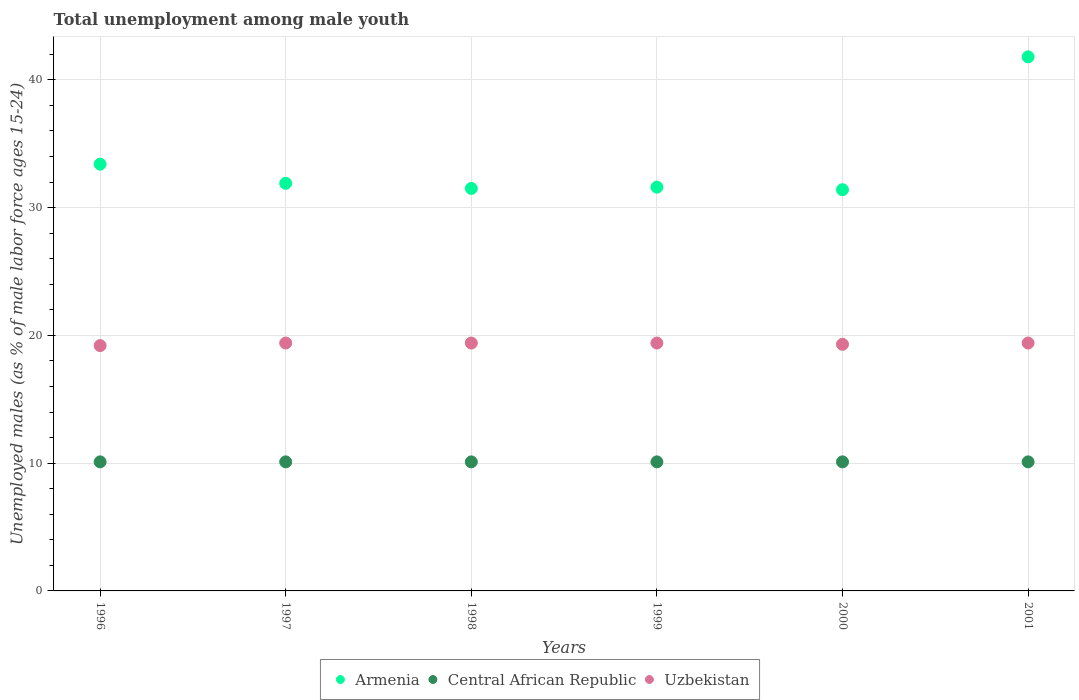How many different coloured dotlines are there?
Ensure brevity in your answer.  3. Is the number of dotlines equal to the number of legend labels?
Your answer should be compact. Yes. What is the percentage of unemployed males in in Central African Republic in 1996?
Offer a very short reply. 10.1. Across all years, what is the maximum percentage of unemployed males in in Armenia?
Offer a very short reply. 41.8. Across all years, what is the minimum percentage of unemployed males in in Central African Republic?
Your answer should be compact. 10.1. What is the total percentage of unemployed males in in Armenia in the graph?
Your answer should be very brief. 201.6. What is the difference between the percentage of unemployed males in in Central African Republic in 1998 and that in 1999?
Provide a succinct answer. 0. What is the difference between the percentage of unemployed males in in Uzbekistan in 1997 and the percentage of unemployed males in in Central African Republic in 1996?
Your answer should be compact. 9.3. What is the average percentage of unemployed males in in Uzbekistan per year?
Provide a succinct answer. 19.35. In the year 1998, what is the difference between the percentage of unemployed males in in Armenia and percentage of unemployed males in in Central African Republic?
Your response must be concise. 21.4. In how many years, is the percentage of unemployed males in in Armenia greater than 2 %?
Offer a terse response. 6. What is the ratio of the percentage of unemployed males in in Armenia in 1997 to that in 1998?
Provide a succinct answer. 1.01. Is the difference between the percentage of unemployed males in in Armenia in 1998 and 2001 greater than the difference between the percentage of unemployed males in in Central African Republic in 1998 and 2001?
Make the answer very short. No. What is the difference between the highest and the lowest percentage of unemployed males in in Armenia?
Provide a short and direct response. 10.4. Is it the case that in every year, the sum of the percentage of unemployed males in in Uzbekistan and percentage of unemployed males in in Armenia  is greater than the percentage of unemployed males in in Central African Republic?
Provide a succinct answer. Yes. Is the percentage of unemployed males in in Armenia strictly greater than the percentage of unemployed males in in Central African Republic over the years?
Offer a terse response. Yes. How many dotlines are there?
Ensure brevity in your answer.  3. How many years are there in the graph?
Keep it short and to the point. 6. Does the graph contain any zero values?
Keep it short and to the point. No. Does the graph contain grids?
Your answer should be compact. Yes. Where does the legend appear in the graph?
Make the answer very short. Bottom center. How many legend labels are there?
Offer a terse response. 3. How are the legend labels stacked?
Offer a terse response. Horizontal. What is the title of the graph?
Offer a very short reply. Total unemployment among male youth. What is the label or title of the Y-axis?
Offer a very short reply. Unemployed males (as % of male labor force ages 15-24). What is the Unemployed males (as % of male labor force ages 15-24) in Armenia in 1996?
Ensure brevity in your answer.  33.4. What is the Unemployed males (as % of male labor force ages 15-24) of Central African Republic in 1996?
Offer a very short reply. 10.1. What is the Unemployed males (as % of male labor force ages 15-24) of Uzbekistan in 1996?
Your answer should be very brief. 19.2. What is the Unemployed males (as % of male labor force ages 15-24) in Armenia in 1997?
Your answer should be compact. 31.9. What is the Unemployed males (as % of male labor force ages 15-24) in Central African Republic in 1997?
Make the answer very short. 10.1. What is the Unemployed males (as % of male labor force ages 15-24) of Uzbekistan in 1997?
Ensure brevity in your answer.  19.4. What is the Unemployed males (as % of male labor force ages 15-24) in Armenia in 1998?
Give a very brief answer. 31.5. What is the Unemployed males (as % of male labor force ages 15-24) of Central African Republic in 1998?
Your answer should be very brief. 10.1. What is the Unemployed males (as % of male labor force ages 15-24) of Uzbekistan in 1998?
Provide a succinct answer. 19.4. What is the Unemployed males (as % of male labor force ages 15-24) in Armenia in 1999?
Provide a short and direct response. 31.6. What is the Unemployed males (as % of male labor force ages 15-24) in Central African Republic in 1999?
Provide a succinct answer. 10.1. What is the Unemployed males (as % of male labor force ages 15-24) of Uzbekistan in 1999?
Give a very brief answer. 19.4. What is the Unemployed males (as % of male labor force ages 15-24) of Armenia in 2000?
Keep it short and to the point. 31.4. What is the Unemployed males (as % of male labor force ages 15-24) of Central African Republic in 2000?
Your answer should be compact. 10.1. What is the Unemployed males (as % of male labor force ages 15-24) of Uzbekistan in 2000?
Make the answer very short. 19.3. What is the Unemployed males (as % of male labor force ages 15-24) in Armenia in 2001?
Make the answer very short. 41.8. What is the Unemployed males (as % of male labor force ages 15-24) of Central African Republic in 2001?
Offer a terse response. 10.1. What is the Unemployed males (as % of male labor force ages 15-24) of Uzbekistan in 2001?
Give a very brief answer. 19.4. Across all years, what is the maximum Unemployed males (as % of male labor force ages 15-24) of Armenia?
Offer a terse response. 41.8. Across all years, what is the maximum Unemployed males (as % of male labor force ages 15-24) in Central African Republic?
Provide a short and direct response. 10.1. Across all years, what is the maximum Unemployed males (as % of male labor force ages 15-24) of Uzbekistan?
Keep it short and to the point. 19.4. Across all years, what is the minimum Unemployed males (as % of male labor force ages 15-24) of Armenia?
Keep it short and to the point. 31.4. Across all years, what is the minimum Unemployed males (as % of male labor force ages 15-24) in Central African Republic?
Ensure brevity in your answer.  10.1. Across all years, what is the minimum Unemployed males (as % of male labor force ages 15-24) of Uzbekistan?
Provide a short and direct response. 19.2. What is the total Unemployed males (as % of male labor force ages 15-24) in Armenia in the graph?
Provide a succinct answer. 201.6. What is the total Unemployed males (as % of male labor force ages 15-24) in Central African Republic in the graph?
Provide a short and direct response. 60.6. What is the total Unemployed males (as % of male labor force ages 15-24) in Uzbekistan in the graph?
Give a very brief answer. 116.1. What is the difference between the Unemployed males (as % of male labor force ages 15-24) in Armenia in 1996 and that in 1997?
Your response must be concise. 1.5. What is the difference between the Unemployed males (as % of male labor force ages 15-24) in Uzbekistan in 1996 and that in 1997?
Ensure brevity in your answer.  -0.2. What is the difference between the Unemployed males (as % of male labor force ages 15-24) of Armenia in 1996 and that in 1999?
Keep it short and to the point. 1.8. What is the difference between the Unemployed males (as % of male labor force ages 15-24) in Central African Republic in 1996 and that in 1999?
Offer a very short reply. 0. What is the difference between the Unemployed males (as % of male labor force ages 15-24) in Armenia in 1996 and that in 2000?
Provide a short and direct response. 2. What is the difference between the Unemployed males (as % of male labor force ages 15-24) in Central African Republic in 1996 and that in 2000?
Your answer should be very brief. 0. What is the difference between the Unemployed males (as % of male labor force ages 15-24) of Armenia in 1996 and that in 2001?
Your answer should be very brief. -8.4. What is the difference between the Unemployed males (as % of male labor force ages 15-24) in Uzbekistan in 1996 and that in 2001?
Your answer should be compact. -0.2. What is the difference between the Unemployed males (as % of male labor force ages 15-24) of Uzbekistan in 1997 and that in 1998?
Offer a terse response. 0. What is the difference between the Unemployed males (as % of male labor force ages 15-24) of Central African Republic in 1997 and that in 1999?
Ensure brevity in your answer.  0. What is the difference between the Unemployed males (as % of male labor force ages 15-24) in Armenia in 1997 and that in 2000?
Provide a short and direct response. 0.5. What is the difference between the Unemployed males (as % of male labor force ages 15-24) in Central African Republic in 1997 and that in 2000?
Offer a very short reply. 0. What is the difference between the Unemployed males (as % of male labor force ages 15-24) in Armenia in 1997 and that in 2001?
Keep it short and to the point. -9.9. What is the difference between the Unemployed males (as % of male labor force ages 15-24) in Uzbekistan in 1997 and that in 2001?
Give a very brief answer. 0. What is the difference between the Unemployed males (as % of male labor force ages 15-24) in Central African Republic in 1998 and that in 1999?
Offer a terse response. 0. What is the difference between the Unemployed males (as % of male labor force ages 15-24) in Uzbekistan in 1998 and that in 1999?
Provide a succinct answer. 0. What is the difference between the Unemployed males (as % of male labor force ages 15-24) in Central African Republic in 1998 and that in 2000?
Provide a short and direct response. 0. What is the difference between the Unemployed males (as % of male labor force ages 15-24) of Central African Republic in 1999 and that in 2000?
Give a very brief answer. 0. What is the difference between the Unemployed males (as % of male labor force ages 15-24) of Uzbekistan in 1999 and that in 2001?
Provide a succinct answer. 0. What is the difference between the Unemployed males (as % of male labor force ages 15-24) of Armenia in 2000 and that in 2001?
Offer a terse response. -10.4. What is the difference between the Unemployed males (as % of male labor force ages 15-24) in Central African Republic in 2000 and that in 2001?
Your answer should be compact. 0. What is the difference between the Unemployed males (as % of male labor force ages 15-24) in Armenia in 1996 and the Unemployed males (as % of male labor force ages 15-24) in Central African Republic in 1997?
Ensure brevity in your answer.  23.3. What is the difference between the Unemployed males (as % of male labor force ages 15-24) of Armenia in 1996 and the Unemployed males (as % of male labor force ages 15-24) of Uzbekistan in 1997?
Ensure brevity in your answer.  14. What is the difference between the Unemployed males (as % of male labor force ages 15-24) of Armenia in 1996 and the Unemployed males (as % of male labor force ages 15-24) of Central African Republic in 1998?
Give a very brief answer. 23.3. What is the difference between the Unemployed males (as % of male labor force ages 15-24) of Armenia in 1996 and the Unemployed males (as % of male labor force ages 15-24) of Uzbekistan in 1998?
Your answer should be compact. 14. What is the difference between the Unemployed males (as % of male labor force ages 15-24) in Armenia in 1996 and the Unemployed males (as % of male labor force ages 15-24) in Central African Republic in 1999?
Provide a succinct answer. 23.3. What is the difference between the Unemployed males (as % of male labor force ages 15-24) of Armenia in 1996 and the Unemployed males (as % of male labor force ages 15-24) of Uzbekistan in 1999?
Ensure brevity in your answer.  14. What is the difference between the Unemployed males (as % of male labor force ages 15-24) in Central African Republic in 1996 and the Unemployed males (as % of male labor force ages 15-24) in Uzbekistan in 1999?
Your answer should be compact. -9.3. What is the difference between the Unemployed males (as % of male labor force ages 15-24) in Armenia in 1996 and the Unemployed males (as % of male labor force ages 15-24) in Central African Republic in 2000?
Ensure brevity in your answer.  23.3. What is the difference between the Unemployed males (as % of male labor force ages 15-24) in Central African Republic in 1996 and the Unemployed males (as % of male labor force ages 15-24) in Uzbekistan in 2000?
Give a very brief answer. -9.2. What is the difference between the Unemployed males (as % of male labor force ages 15-24) in Armenia in 1996 and the Unemployed males (as % of male labor force ages 15-24) in Central African Republic in 2001?
Your answer should be compact. 23.3. What is the difference between the Unemployed males (as % of male labor force ages 15-24) of Central African Republic in 1996 and the Unemployed males (as % of male labor force ages 15-24) of Uzbekistan in 2001?
Provide a succinct answer. -9.3. What is the difference between the Unemployed males (as % of male labor force ages 15-24) of Armenia in 1997 and the Unemployed males (as % of male labor force ages 15-24) of Central African Republic in 1998?
Ensure brevity in your answer.  21.8. What is the difference between the Unemployed males (as % of male labor force ages 15-24) of Armenia in 1997 and the Unemployed males (as % of male labor force ages 15-24) of Uzbekistan in 1998?
Provide a short and direct response. 12.5. What is the difference between the Unemployed males (as % of male labor force ages 15-24) in Armenia in 1997 and the Unemployed males (as % of male labor force ages 15-24) in Central African Republic in 1999?
Provide a short and direct response. 21.8. What is the difference between the Unemployed males (as % of male labor force ages 15-24) of Armenia in 1997 and the Unemployed males (as % of male labor force ages 15-24) of Central African Republic in 2000?
Provide a succinct answer. 21.8. What is the difference between the Unemployed males (as % of male labor force ages 15-24) of Central African Republic in 1997 and the Unemployed males (as % of male labor force ages 15-24) of Uzbekistan in 2000?
Your answer should be compact. -9.2. What is the difference between the Unemployed males (as % of male labor force ages 15-24) in Armenia in 1997 and the Unemployed males (as % of male labor force ages 15-24) in Central African Republic in 2001?
Ensure brevity in your answer.  21.8. What is the difference between the Unemployed males (as % of male labor force ages 15-24) of Central African Republic in 1997 and the Unemployed males (as % of male labor force ages 15-24) of Uzbekistan in 2001?
Offer a terse response. -9.3. What is the difference between the Unemployed males (as % of male labor force ages 15-24) in Armenia in 1998 and the Unemployed males (as % of male labor force ages 15-24) in Central African Republic in 1999?
Ensure brevity in your answer.  21.4. What is the difference between the Unemployed males (as % of male labor force ages 15-24) of Armenia in 1998 and the Unemployed males (as % of male labor force ages 15-24) of Central African Republic in 2000?
Ensure brevity in your answer.  21.4. What is the difference between the Unemployed males (as % of male labor force ages 15-24) in Armenia in 1998 and the Unemployed males (as % of male labor force ages 15-24) in Uzbekistan in 2000?
Make the answer very short. 12.2. What is the difference between the Unemployed males (as % of male labor force ages 15-24) of Central African Republic in 1998 and the Unemployed males (as % of male labor force ages 15-24) of Uzbekistan in 2000?
Keep it short and to the point. -9.2. What is the difference between the Unemployed males (as % of male labor force ages 15-24) in Armenia in 1998 and the Unemployed males (as % of male labor force ages 15-24) in Central African Republic in 2001?
Ensure brevity in your answer.  21.4. What is the difference between the Unemployed males (as % of male labor force ages 15-24) of Central African Republic in 1998 and the Unemployed males (as % of male labor force ages 15-24) of Uzbekistan in 2001?
Give a very brief answer. -9.3. What is the difference between the Unemployed males (as % of male labor force ages 15-24) of Central African Republic in 1999 and the Unemployed males (as % of male labor force ages 15-24) of Uzbekistan in 2000?
Make the answer very short. -9.2. What is the difference between the Unemployed males (as % of male labor force ages 15-24) in Armenia in 2000 and the Unemployed males (as % of male labor force ages 15-24) in Central African Republic in 2001?
Your answer should be compact. 21.3. What is the difference between the Unemployed males (as % of male labor force ages 15-24) of Central African Republic in 2000 and the Unemployed males (as % of male labor force ages 15-24) of Uzbekistan in 2001?
Provide a short and direct response. -9.3. What is the average Unemployed males (as % of male labor force ages 15-24) in Armenia per year?
Keep it short and to the point. 33.6. What is the average Unemployed males (as % of male labor force ages 15-24) of Central African Republic per year?
Your response must be concise. 10.1. What is the average Unemployed males (as % of male labor force ages 15-24) in Uzbekistan per year?
Give a very brief answer. 19.35. In the year 1996, what is the difference between the Unemployed males (as % of male labor force ages 15-24) of Armenia and Unemployed males (as % of male labor force ages 15-24) of Central African Republic?
Ensure brevity in your answer.  23.3. In the year 1996, what is the difference between the Unemployed males (as % of male labor force ages 15-24) of Armenia and Unemployed males (as % of male labor force ages 15-24) of Uzbekistan?
Keep it short and to the point. 14.2. In the year 1996, what is the difference between the Unemployed males (as % of male labor force ages 15-24) in Central African Republic and Unemployed males (as % of male labor force ages 15-24) in Uzbekistan?
Your answer should be very brief. -9.1. In the year 1997, what is the difference between the Unemployed males (as % of male labor force ages 15-24) in Armenia and Unemployed males (as % of male labor force ages 15-24) in Central African Republic?
Make the answer very short. 21.8. In the year 1997, what is the difference between the Unemployed males (as % of male labor force ages 15-24) in Central African Republic and Unemployed males (as % of male labor force ages 15-24) in Uzbekistan?
Provide a short and direct response. -9.3. In the year 1998, what is the difference between the Unemployed males (as % of male labor force ages 15-24) of Armenia and Unemployed males (as % of male labor force ages 15-24) of Central African Republic?
Your answer should be compact. 21.4. In the year 1998, what is the difference between the Unemployed males (as % of male labor force ages 15-24) in Armenia and Unemployed males (as % of male labor force ages 15-24) in Uzbekistan?
Give a very brief answer. 12.1. In the year 1999, what is the difference between the Unemployed males (as % of male labor force ages 15-24) of Central African Republic and Unemployed males (as % of male labor force ages 15-24) of Uzbekistan?
Your answer should be very brief. -9.3. In the year 2000, what is the difference between the Unemployed males (as % of male labor force ages 15-24) in Armenia and Unemployed males (as % of male labor force ages 15-24) in Central African Republic?
Make the answer very short. 21.3. In the year 2000, what is the difference between the Unemployed males (as % of male labor force ages 15-24) of Armenia and Unemployed males (as % of male labor force ages 15-24) of Uzbekistan?
Make the answer very short. 12.1. In the year 2000, what is the difference between the Unemployed males (as % of male labor force ages 15-24) in Central African Republic and Unemployed males (as % of male labor force ages 15-24) in Uzbekistan?
Provide a short and direct response. -9.2. In the year 2001, what is the difference between the Unemployed males (as % of male labor force ages 15-24) in Armenia and Unemployed males (as % of male labor force ages 15-24) in Central African Republic?
Your answer should be compact. 31.7. In the year 2001, what is the difference between the Unemployed males (as % of male labor force ages 15-24) of Armenia and Unemployed males (as % of male labor force ages 15-24) of Uzbekistan?
Provide a succinct answer. 22.4. In the year 2001, what is the difference between the Unemployed males (as % of male labor force ages 15-24) of Central African Republic and Unemployed males (as % of male labor force ages 15-24) of Uzbekistan?
Your answer should be compact. -9.3. What is the ratio of the Unemployed males (as % of male labor force ages 15-24) in Armenia in 1996 to that in 1997?
Offer a very short reply. 1.05. What is the ratio of the Unemployed males (as % of male labor force ages 15-24) of Central African Republic in 1996 to that in 1997?
Offer a very short reply. 1. What is the ratio of the Unemployed males (as % of male labor force ages 15-24) in Armenia in 1996 to that in 1998?
Your response must be concise. 1.06. What is the ratio of the Unemployed males (as % of male labor force ages 15-24) in Armenia in 1996 to that in 1999?
Your answer should be very brief. 1.06. What is the ratio of the Unemployed males (as % of male labor force ages 15-24) of Central African Republic in 1996 to that in 1999?
Your response must be concise. 1. What is the ratio of the Unemployed males (as % of male labor force ages 15-24) of Armenia in 1996 to that in 2000?
Make the answer very short. 1.06. What is the ratio of the Unemployed males (as % of male labor force ages 15-24) of Central African Republic in 1996 to that in 2000?
Your answer should be very brief. 1. What is the ratio of the Unemployed males (as % of male labor force ages 15-24) of Armenia in 1996 to that in 2001?
Ensure brevity in your answer.  0.8. What is the ratio of the Unemployed males (as % of male labor force ages 15-24) of Armenia in 1997 to that in 1998?
Offer a terse response. 1.01. What is the ratio of the Unemployed males (as % of male labor force ages 15-24) in Central African Republic in 1997 to that in 1998?
Offer a terse response. 1. What is the ratio of the Unemployed males (as % of male labor force ages 15-24) in Uzbekistan in 1997 to that in 1998?
Provide a short and direct response. 1. What is the ratio of the Unemployed males (as % of male labor force ages 15-24) in Armenia in 1997 to that in 1999?
Give a very brief answer. 1.01. What is the ratio of the Unemployed males (as % of male labor force ages 15-24) of Armenia in 1997 to that in 2000?
Provide a short and direct response. 1.02. What is the ratio of the Unemployed males (as % of male labor force ages 15-24) of Central African Republic in 1997 to that in 2000?
Offer a very short reply. 1. What is the ratio of the Unemployed males (as % of male labor force ages 15-24) in Uzbekistan in 1997 to that in 2000?
Your answer should be very brief. 1.01. What is the ratio of the Unemployed males (as % of male labor force ages 15-24) of Armenia in 1997 to that in 2001?
Give a very brief answer. 0.76. What is the ratio of the Unemployed males (as % of male labor force ages 15-24) in Central African Republic in 1997 to that in 2001?
Provide a succinct answer. 1. What is the ratio of the Unemployed males (as % of male labor force ages 15-24) in Uzbekistan in 1997 to that in 2001?
Your response must be concise. 1. What is the ratio of the Unemployed males (as % of male labor force ages 15-24) of Central African Republic in 1998 to that in 1999?
Give a very brief answer. 1. What is the ratio of the Unemployed males (as % of male labor force ages 15-24) of Armenia in 1998 to that in 2000?
Ensure brevity in your answer.  1. What is the ratio of the Unemployed males (as % of male labor force ages 15-24) of Armenia in 1998 to that in 2001?
Give a very brief answer. 0.75. What is the ratio of the Unemployed males (as % of male labor force ages 15-24) of Uzbekistan in 1998 to that in 2001?
Keep it short and to the point. 1. What is the ratio of the Unemployed males (as % of male labor force ages 15-24) of Armenia in 1999 to that in 2000?
Provide a succinct answer. 1.01. What is the ratio of the Unemployed males (as % of male labor force ages 15-24) of Central African Republic in 1999 to that in 2000?
Offer a very short reply. 1. What is the ratio of the Unemployed males (as % of male labor force ages 15-24) of Uzbekistan in 1999 to that in 2000?
Keep it short and to the point. 1.01. What is the ratio of the Unemployed males (as % of male labor force ages 15-24) in Armenia in 1999 to that in 2001?
Make the answer very short. 0.76. What is the ratio of the Unemployed males (as % of male labor force ages 15-24) in Central African Republic in 1999 to that in 2001?
Provide a succinct answer. 1. What is the ratio of the Unemployed males (as % of male labor force ages 15-24) of Armenia in 2000 to that in 2001?
Provide a short and direct response. 0.75. What is the ratio of the Unemployed males (as % of male labor force ages 15-24) of Central African Republic in 2000 to that in 2001?
Keep it short and to the point. 1. What is the ratio of the Unemployed males (as % of male labor force ages 15-24) in Uzbekistan in 2000 to that in 2001?
Provide a short and direct response. 0.99. What is the difference between the highest and the second highest Unemployed males (as % of male labor force ages 15-24) of Central African Republic?
Ensure brevity in your answer.  0. What is the difference between the highest and the lowest Unemployed males (as % of male labor force ages 15-24) in Armenia?
Give a very brief answer. 10.4. 